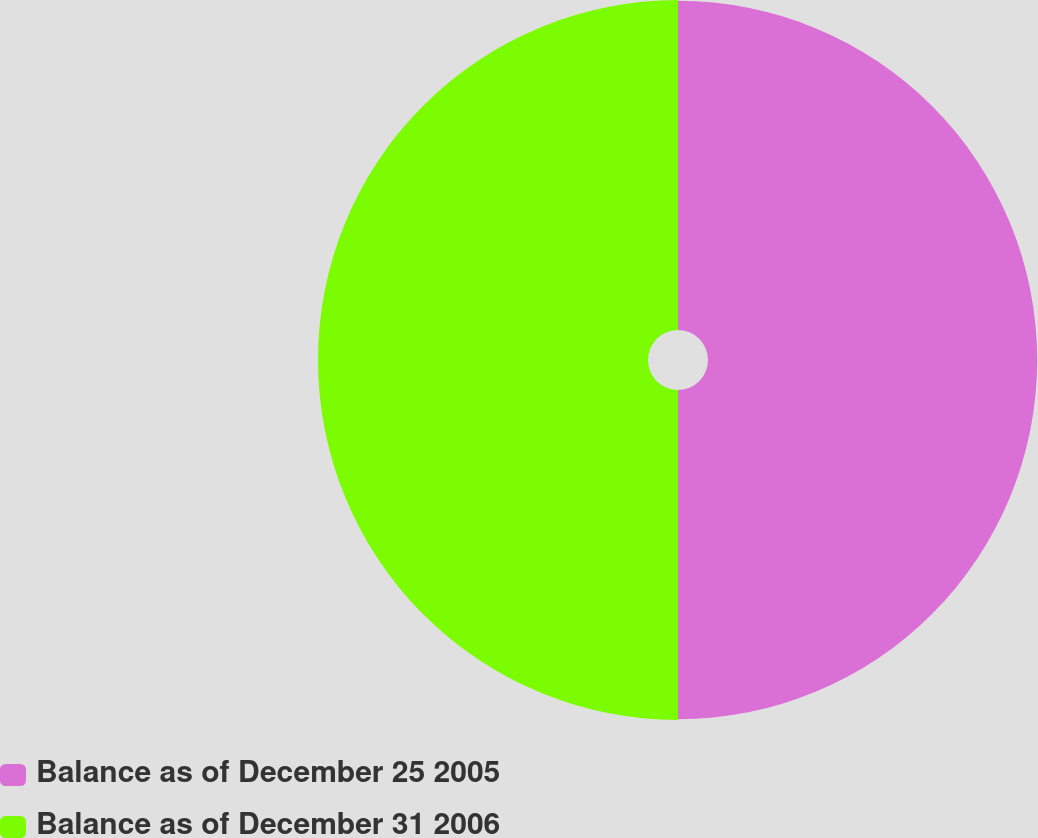Convert chart to OTSL. <chart><loc_0><loc_0><loc_500><loc_500><pie_chart><fcel>Balance as of December 25 2005<fcel>Balance as of December 31 2006<nl><fcel>49.94%<fcel>50.06%<nl></chart> 